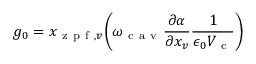Convert formula to latex. <formula><loc_0><loc_0><loc_500><loc_500>g _ { 0 } = { x _ { z p f , v } } \left ( \omega _ { c a v } \frac { \partial \alpha } { \partial x _ { v } } \frac { 1 } { \epsilon _ { 0 } V _ { c } } \right )</formula> 